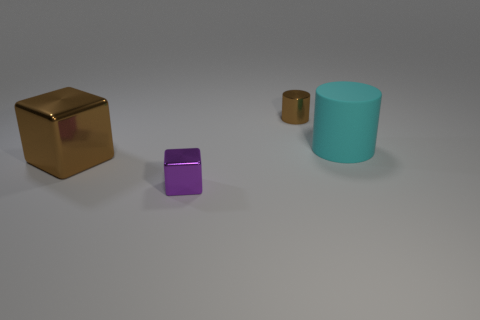What mood do the colors and arrangement of the objects in the image evoke? The colors of the objects are muted, with a gold, a purple, and a cyan object, all of which are set against a neutral gray background. The arrangement is orderly but somewhat sparse, evoking a sense of minimalist calm or stillness. It could be interpreted as a study in color and simple geometric shapes, reminiscent of an art installation. 